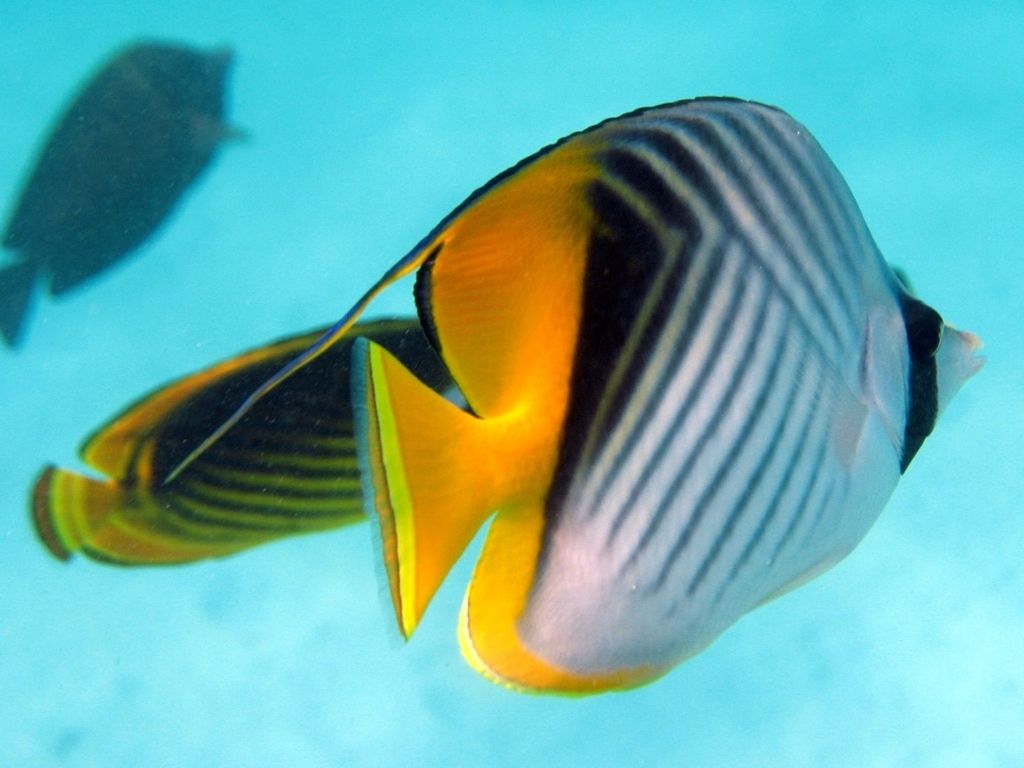Explore the quality factors of the image and offer an evaluation based on your insights.
 The clarity of this photo is acceptable, with some noise. There is no false image, and the composition highlights the subject - tropical fish. The colors are vibrant, and the content is well-filled. The focus is also on the fish's body. Therefore, the quality of this photo is satisfactory. 